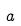<formula> <loc_0><loc_0><loc_500><loc_500>a</formula> 